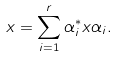Convert formula to latex. <formula><loc_0><loc_0><loc_500><loc_500>x = \sum _ { i = 1 } ^ { r } \alpha _ { i } ^ { * } x \alpha _ { i } .</formula> 